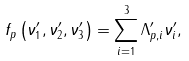<formula> <loc_0><loc_0><loc_500><loc_500>f _ { p } \left ( \nu ^ { \prime } _ { 1 } , \nu ^ { \prime } _ { 2 } , \nu ^ { \prime } _ { 3 } \right ) & = \sum _ { i = 1 } ^ { 3 } \Lambda ^ { \prime } _ { p , i } \nu ^ { \prime } _ { i } ,</formula> 